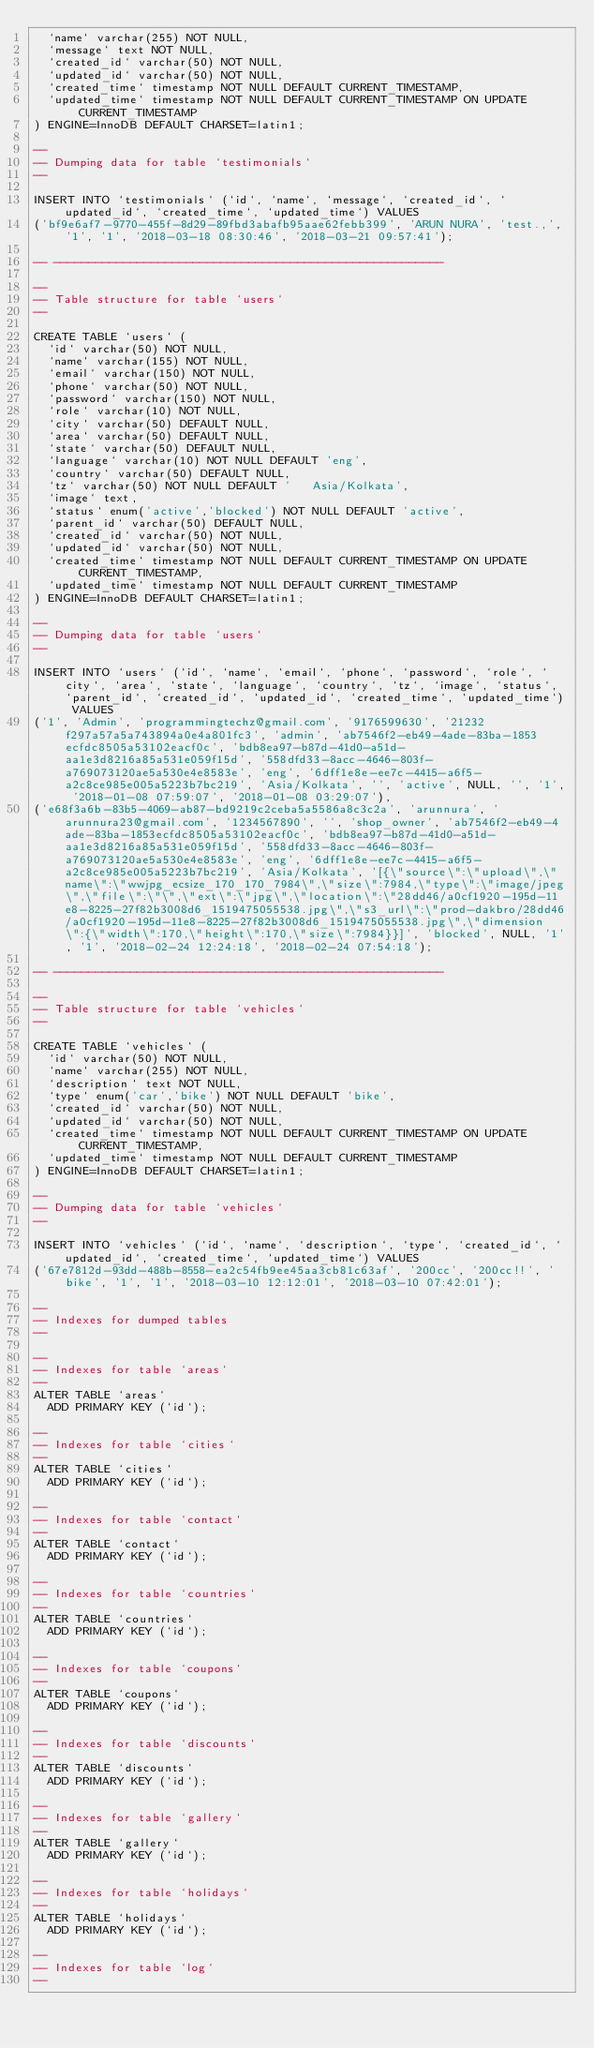<code> <loc_0><loc_0><loc_500><loc_500><_SQL_>  `name` varchar(255) NOT NULL,
  `message` text NOT NULL,
  `created_id` varchar(50) NOT NULL,
  `updated_id` varchar(50) NOT NULL,
  `created_time` timestamp NOT NULL DEFAULT CURRENT_TIMESTAMP,
  `updated_time` timestamp NOT NULL DEFAULT CURRENT_TIMESTAMP ON UPDATE CURRENT_TIMESTAMP
) ENGINE=InnoDB DEFAULT CHARSET=latin1;

--
-- Dumping data for table `testimonials`
--

INSERT INTO `testimonials` (`id`, `name`, `message`, `created_id`, `updated_id`, `created_time`, `updated_time`) VALUES
('bf9e6af7-9770-455f-8d29-89fbd3abafb95aae62febb399', 'ARUN NURA', 'test.,', '1', '1', '2018-03-18 08:30:46', '2018-03-21 09:57:41');

-- --------------------------------------------------------

--
-- Table structure for table `users`
--

CREATE TABLE `users` (
  `id` varchar(50) NOT NULL,
  `name` varchar(155) NOT NULL,
  `email` varchar(150) NOT NULL,
  `phone` varchar(50) NOT NULL,
  `password` varchar(150) NOT NULL,
  `role` varchar(10) NOT NULL,
  `city` varchar(50) DEFAULT NULL,
  `area` varchar(50) DEFAULT NULL,
  `state` varchar(50) DEFAULT NULL,
  `language` varchar(10) NOT NULL DEFAULT 'eng',
  `country` varchar(50) DEFAULT NULL,
  `tz` varchar(50) NOT NULL DEFAULT '	Asia/Kolkata',
  `image` text,
  `status` enum('active','blocked') NOT NULL DEFAULT 'active',
  `parent_id` varchar(50) DEFAULT NULL,
  `created_id` varchar(50) NOT NULL,
  `updated_id` varchar(50) NOT NULL,
  `created_time` timestamp NOT NULL DEFAULT CURRENT_TIMESTAMP ON UPDATE CURRENT_TIMESTAMP,
  `updated_time` timestamp NOT NULL DEFAULT CURRENT_TIMESTAMP
) ENGINE=InnoDB DEFAULT CHARSET=latin1;

--
-- Dumping data for table `users`
--

INSERT INTO `users` (`id`, `name`, `email`, `phone`, `password`, `role`, `city`, `area`, `state`, `language`, `country`, `tz`, `image`, `status`, `parent_id`, `created_id`, `updated_id`, `created_time`, `updated_time`) VALUES
('1', 'Admin', 'programmingtechz@gmail.com', '9176599630', '21232f297a57a5a743894a0e4a801fc3', 'admin', 'ab7546f2-eb49-4ade-83ba-1853ecfdc8505a53102eacf0c', 'bdb8ea97-b87d-41d0-a51d-aa1e3d8216a85a531e059f15d', '558dfd33-8acc-4646-803f-a769073120ae5a530e4e8583e', 'eng', '6dff1e8e-ee7c-4415-a6f5-a2c8ce985e005a5223b7bc219', 'Asia/Kolkata', '', 'active', NULL, '', '1', '2018-01-08 07:59:07', '2018-01-08 03:29:07'),
('e68f3a6b-83b5-4069-ab87-bd9219c2ceba5a5586a8c3c2a', 'arunnura', 'arunnura23@gmail.com', '1234567890', '', 'shop_owner', 'ab7546f2-eb49-4ade-83ba-1853ecfdc8505a53102eacf0c', 'bdb8ea97-b87d-41d0-a51d-aa1e3d8216a85a531e059f15d', '558dfd33-8acc-4646-803f-a769073120ae5a530e4e8583e', 'eng', '6dff1e8e-ee7c-4415-a6f5-a2c8ce985e005a5223b7bc219', 'Asia/Kolkata', '[{\"source\":\"upload\",\"name\":\"wwjpg_ecsize_170_170_7984\",\"size\":7984,\"type\":\"image/jpeg\",\"file\":\"\",\"ext\":\"jpg\",\"location\":\"28dd46/a0cf1920-195d-11e8-8225-27f82b3008d6_1519475055538.jpg\",\"s3_url\":\"prod-dakbro/28dd46/a0cf1920-195d-11e8-8225-27f82b3008d6_1519475055538.jpg\",\"dimension\":{\"width\":170,\"height\":170,\"size\":7984}}]', 'blocked', NULL, '1', '1', '2018-02-24 12:24:18', '2018-02-24 07:54:18');

-- --------------------------------------------------------

--
-- Table structure for table `vehicles`
--

CREATE TABLE `vehicles` (
  `id` varchar(50) NOT NULL,
  `name` varchar(255) NOT NULL,
  `description` text NOT NULL,
  `type` enum('car','bike') NOT NULL DEFAULT 'bike',
  `created_id` varchar(50) NOT NULL,
  `updated_id` varchar(50) NOT NULL,
  `created_time` timestamp NOT NULL DEFAULT CURRENT_TIMESTAMP ON UPDATE CURRENT_TIMESTAMP,
  `updated_time` timestamp NOT NULL DEFAULT CURRENT_TIMESTAMP
) ENGINE=InnoDB DEFAULT CHARSET=latin1;

--
-- Dumping data for table `vehicles`
--

INSERT INTO `vehicles` (`id`, `name`, `description`, `type`, `created_id`, `updated_id`, `created_time`, `updated_time`) VALUES
('67e7812d-93dd-488b-8558-ea2c54fb9ee45aa3cb81c63af', '200cc', '200cc!!', 'bike', '1', '1', '2018-03-10 12:12:01', '2018-03-10 07:42:01');

--
-- Indexes for dumped tables
--

--
-- Indexes for table `areas`
--
ALTER TABLE `areas`
  ADD PRIMARY KEY (`id`);

--
-- Indexes for table `cities`
--
ALTER TABLE `cities`
  ADD PRIMARY KEY (`id`);

--
-- Indexes for table `contact`
--
ALTER TABLE `contact`
  ADD PRIMARY KEY (`id`);

--
-- Indexes for table `countries`
--
ALTER TABLE `countries`
  ADD PRIMARY KEY (`id`);

--
-- Indexes for table `coupons`
--
ALTER TABLE `coupons`
  ADD PRIMARY KEY (`id`);

--
-- Indexes for table `discounts`
--
ALTER TABLE `discounts`
  ADD PRIMARY KEY (`id`);

--
-- Indexes for table `gallery`
--
ALTER TABLE `gallery`
  ADD PRIMARY KEY (`id`);

--
-- Indexes for table `holidays`
--
ALTER TABLE `holidays`
  ADD PRIMARY KEY (`id`);

--
-- Indexes for table `log`
--</code> 